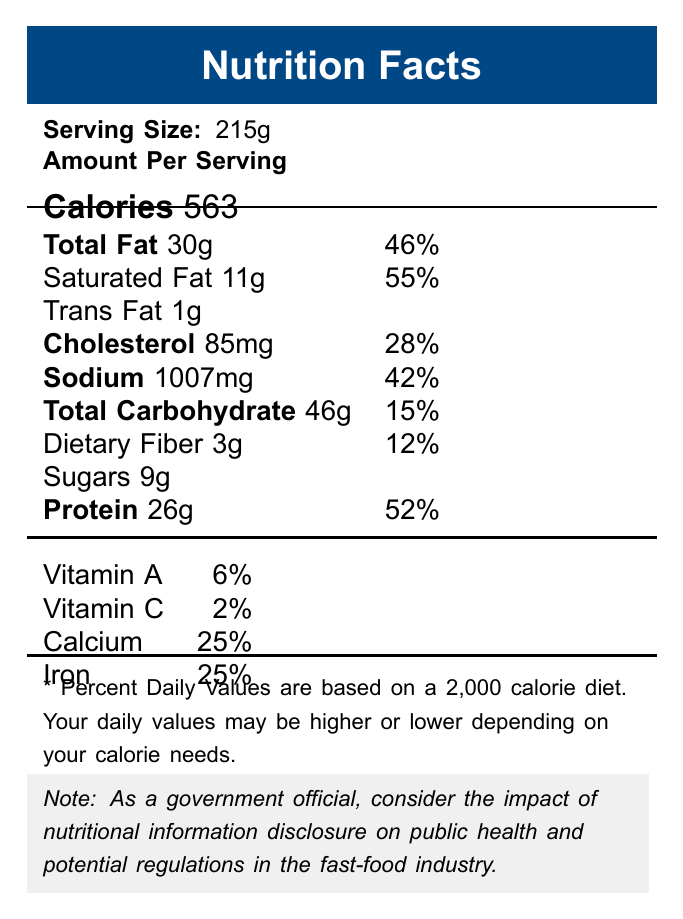what is the serving size mentioned in the document? The serving size is clearly indicated at the top, under the title "Serving Size."
Answer: 215g which food item contains the highest amount of total fat based on the information provided? A. Big Mac B. Whopper C. Spicy Chicken Sandwich D. Crunchy Taco E. 6-inch Tuna Sub The Whopper contains 40g of total fat, which is higher than the other items listed.
Answer: B what percentage of the daily value of iron does the Big Mac provide? The document lists the iron content as 25% in the vitamins and minerals section.
Answer: 25% does the Big Mac contain any trans fat? It is mentioned that the Big Mac contains 1g of Trans Fat.
Answer: Yes are the daily values in the document based on a 2,000 calorie diet? This information is included at the bottom of the document in a footnote.
Answer: Yes which nutrient has the highest daily value percentage in the Big Mac? A. Total Fat B. Saturated Fat C. Sodium D. Protein Saturated Fat has a daily value percentage of 55%, which is the highest among the nutrients listed.
Answer: B how many grams of protein does the Big Mac contain? The amount of protein is listed as 26g in the data visualization.
Answer: 26g which fast-food meal has the lowest sodium content? The Crunchy Taco contains 310mg of sodium, which is the lowest compared to other items listed.
Answer: Crunchy Taco is the total carbohydrate content in the Big Mac low compared to the daily value percentage mentioned? The total carbohydrate content in the Big Mac is 46g, which is listed as 15% of the daily value, not particularly low.
Answer: No summarize the main focus of the visualized document. The document lays out key nutritional information such as calories, fat, cholesterol, sodium, carbohydrates, and vitamins, and emphasizes the importance of understanding these values in the context of a 2,000 calorie diet.
Answer: This document provides the nutritional facts for a fast-food item, specifically highlighting serving size, calorie count, and various nutrient contents along with their respective daily values. does the document give information on dietary fibers? The document lists dietary fiber content as 3g.
Answer: Yes does the document specify the vitamin content for B vitamins? The document only provides information on Vitamin A and Vitamin C but does not specify details about B vitamins.
Answer: Not enough information 